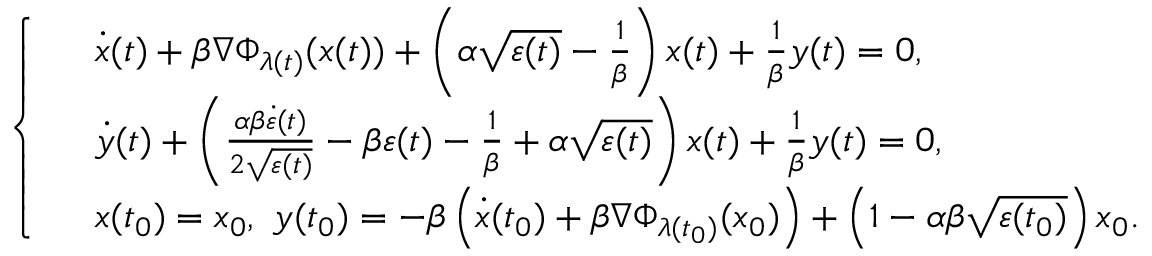<formula> <loc_0><loc_0><loc_500><loc_500>\left \{ \begin{array} { l l } & { \dot { x } ( t ) + \beta \nabla \Phi _ { \lambda ( t ) } ( x ( t ) ) + \left ( \alpha \sqrt { \varepsilon ( t ) } - \frac { 1 } { \beta } \right ) x ( t ) + \frac { 1 } { \beta } y ( t ) = 0 , } \\ & { \dot { y } ( t ) + \left ( \frac { \alpha \beta \dot { \varepsilon } ( t ) } { 2 \sqrt { \varepsilon ( t ) } } - \beta \varepsilon ( t ) - \frac { 1 } { \beta } + \alpha \sqrt { \varepsilon ( t ) } \right ) x ( t ) + \frac { 1 } { \beta } y ( t ) = 0 , } \\ & { x ( t _ { 0 } ) = x _ { 0 } , \ y ( t _ { 0 } ) = - \beta \left ( \dot { x } ( t _ { 0 } ) + \beta \nabla \Phi _ { \lambda ( t _ { 0 } ) } ( x _ { 0 } ) \right ) + \left ( 1 - \alpha \beta \sqrt { \varepsilon ( t _ { 0 } ) } \right ) x _ { 0 } . } \end{array}</formula> 